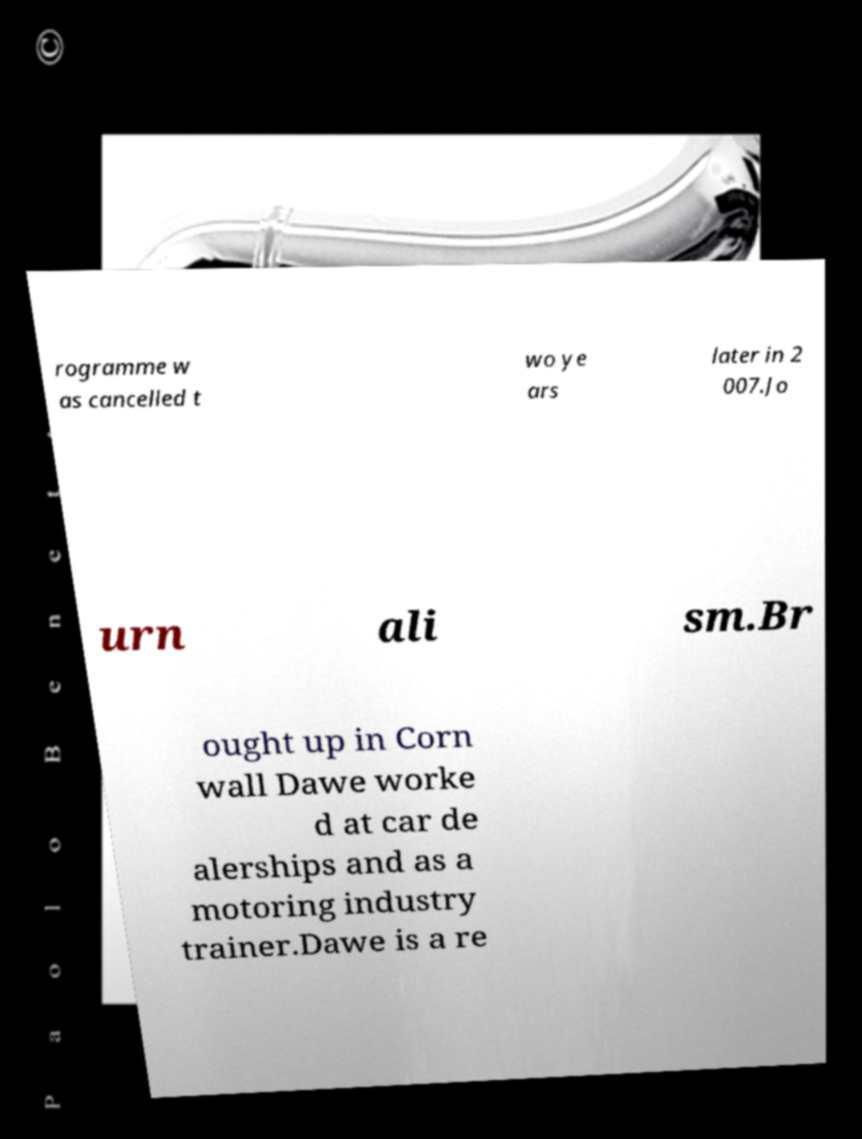Can you accurately transcribe the text from the provided image for me? rogramme w as cancelled t wo ye ars later in 2 007.Jo urn ali sm.Br ought up in Corn wall Dawe worke d at car de alerships and as a motoring industry trainer.Dawe is a re 